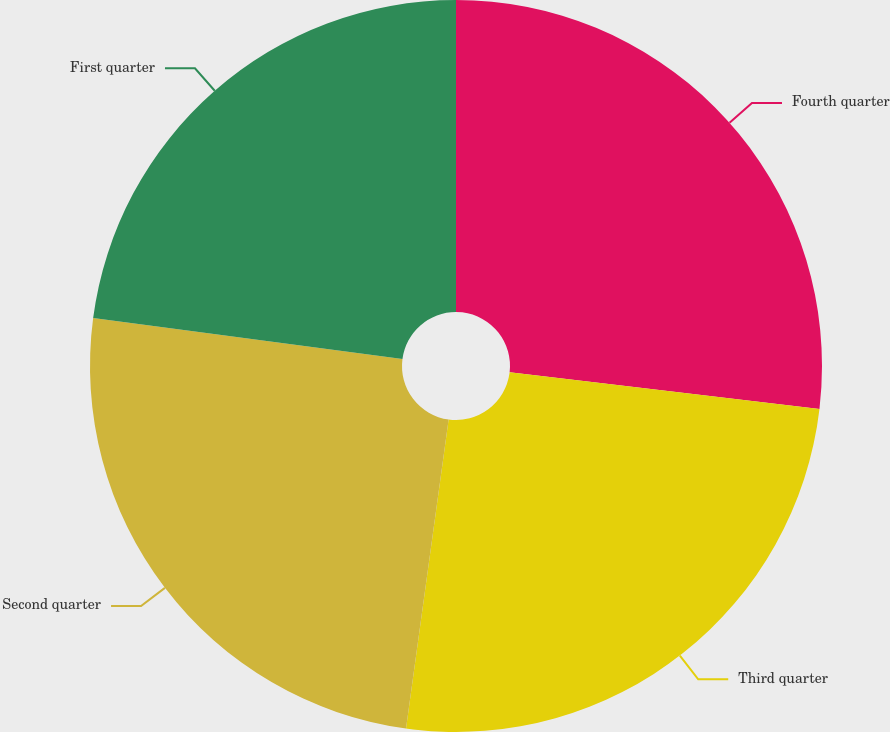Convert chart to OTSL. <chart><loc_0><loc_0><loc_500><loc_500><pie_chart><fcel>Fourth quarter<fcel>Third quarter<fcel>Second quarter<fcel>First quarter<nl><fcel>26.87%<fcel>25.31%<fcel>24.91%<fcel>22.91%<nl></chart> 